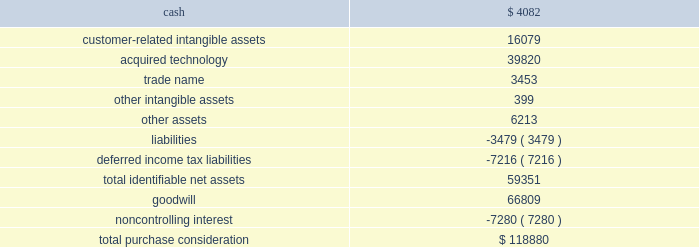Strategy to provide omni-channel solutions that combine gateway services , payment service provisioning and merchant acquiring across europe .
This transaction was accounted for as a business combination .
We recorded the assets acquired , liabilities assumed and noncontrolling interest at their estimated fair values as of the acquisition date .
In connection with the acquisition of realex , we paid a transaction-related tax of $ 1.2 million .
Other acquisition costs were not material .
The revenue and earnings of realex for the year ended may 31 , 2015 were not material nor were the historical revenue and earnings of realex material for the purpose of presenting pro forma information for the current or prior-year periods .
The estimated acquisition date fair values of the assets acquired , liabilities assumed and the noncontrolling interest , including a reconciliation to the total purchase consideration , are as follows ( in thousands ) : .
Goodwill of $ 66.8 million arising from the acquisition , included in the europe segment , was attributable to expected growth opportunities in europe , potential synergies from combining our existing business with gateway services and payment service provisioning in certain markets and an assembled workforce to support the newly acquired technology .
Goodwill associated with this acquisition is not deductible for income tax purposes .
The customer-related intangible assets have an estimated amortization period of 16 years .
The acquired technology has an estimated amortization period of 10 years .
The trade name has an estimated amortization period of 7 years .
On october 5 , 2015 , we paid 20ac6.7 million ( $ 7.5 million equivalent as of october 5 , 2015 ) to acquire the remaining shares of realex after which we own 100% ( 100 % ) of the outstanding shares .
Ezidebit on october 10 , 2014 , we completed the acquisition of 100% ( 100 % ) of the outstanding stock of ezi holdings pty ltd ( 201cezidebit 201d ) for aud302.6 million in cash ( $ 266.0 million equivalent as of the acquisition date ) .
This acquisition was funded by a combination of cash on hand and borrowings on our revolving credit facility .
Ezidebit is a leading integrated payments company focused on recurring payments verticals in australia and new zealand .
Ezidebit markets its services through a network of integrated software vendors and direct channels to numerous vertical markets .
We acquired ezidebit to establish a direct distribution channel in australia and new zealand and to further enhance our existing integrated solutions offerings .
This transaction was accounted for as a business combination .
We recorded the assets acquired and liabilities assumed at their estimated fair values as of the acquisition date .
Certain adjustments to estimated fair value were recorded during the year ended may 31 , 2016 based on new information obtained that existed as of the acquisition date .
During the measurement period , management determined that deferred income taxes should be reflected for certain nondeductible intangible assets .
Measurement-period adjustments , which are reflected in the table below , had no material effect on earnings or other comprehensive income for the current or prior periods .
The revenue and earnings of ezidebit global payments inc .
| 2016 form 10-k annual report 2013 69 .
What percentage of the total purchase consideration is comprised of acquired technology? 
Computations: (39820 / 118880)
Answer: 0.33496. 